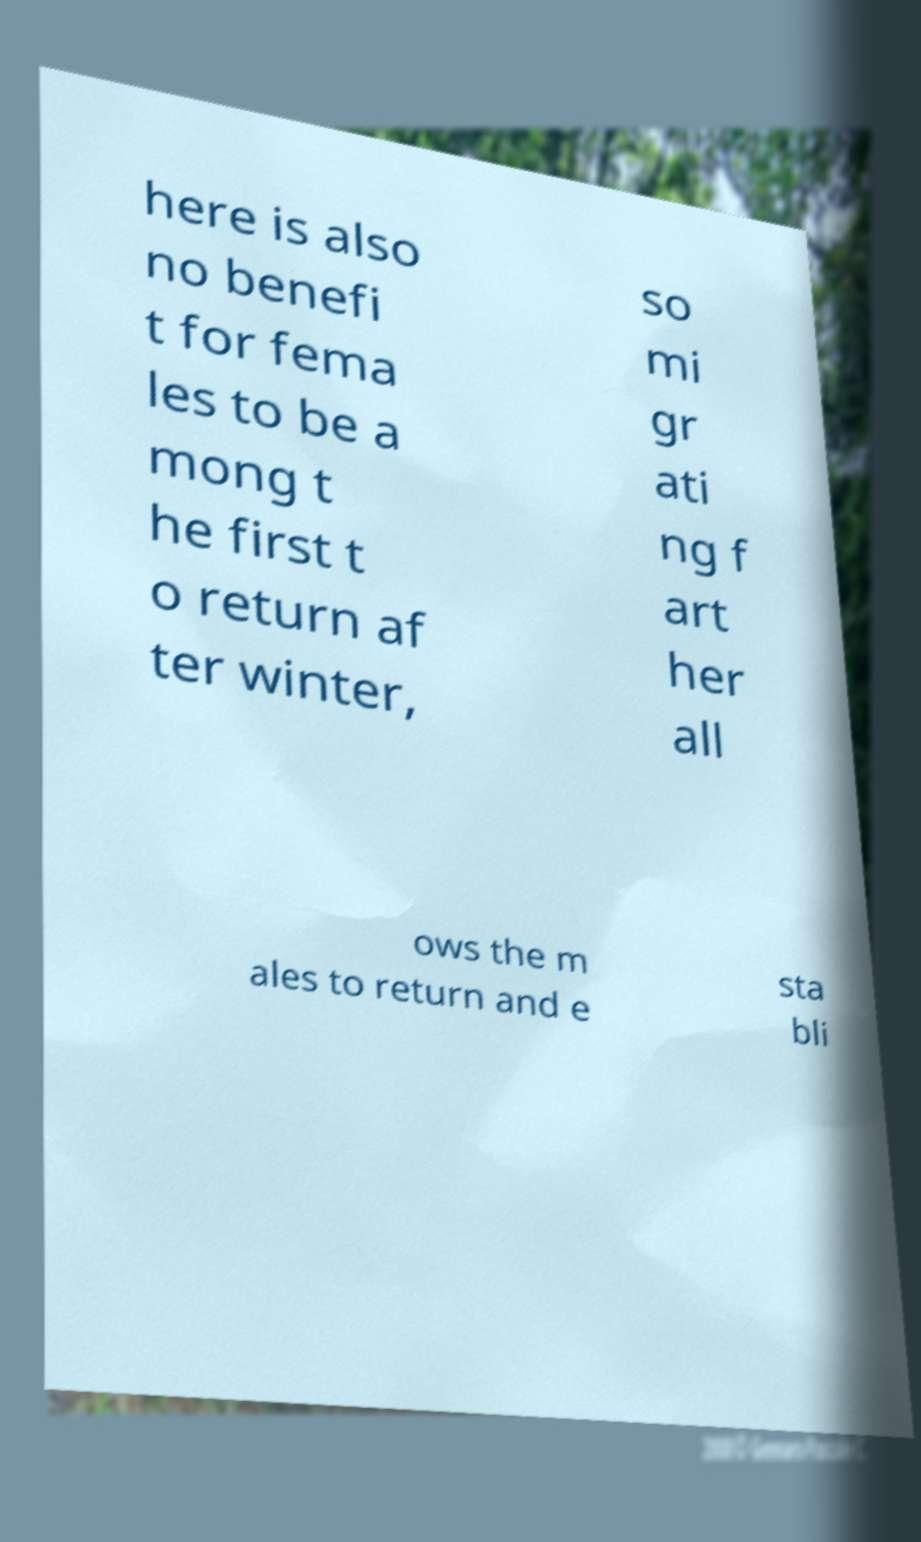I need the written content from this picture converted into text. Can you do that? here is also no benefi t for fema les to be a mong t he first t o return af ter winter, so mi gr ati ng f art her all ows the m ales to return and e sta bli 